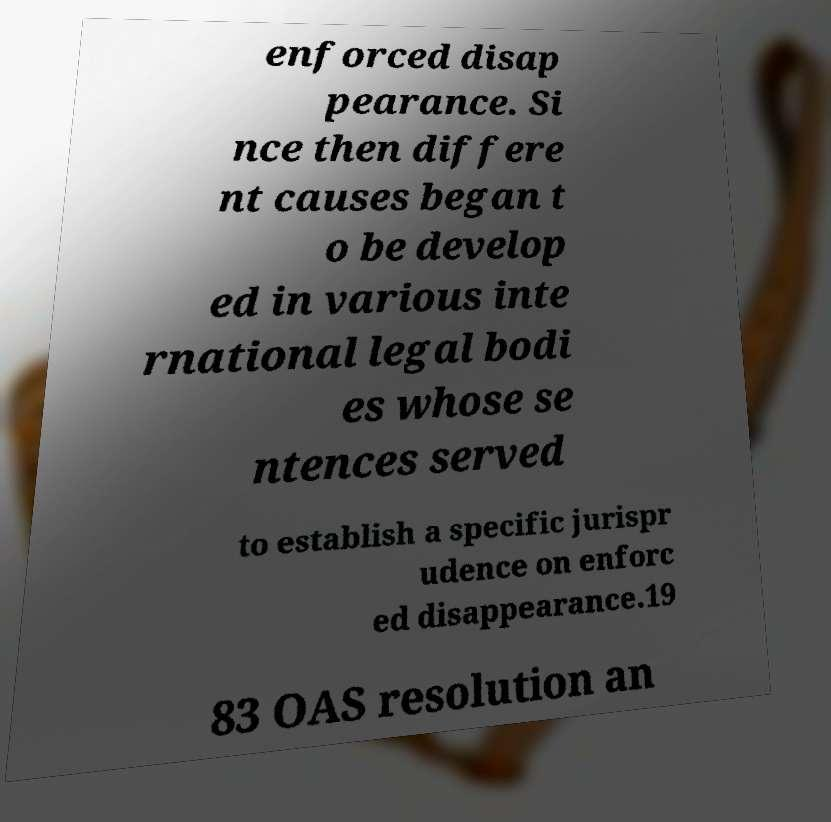Can you read and provide the text displayed in the image?This photo seems to have some interesting text. Can you extract and type it out for me? enforced disap pearance. Si nce then differe nt causes began t o be develop ed in various inte rnational legal bodi es whose se ntences served to establish a specific jurispr udence on enforc ed disappearance.19 83 OAS resolution an 